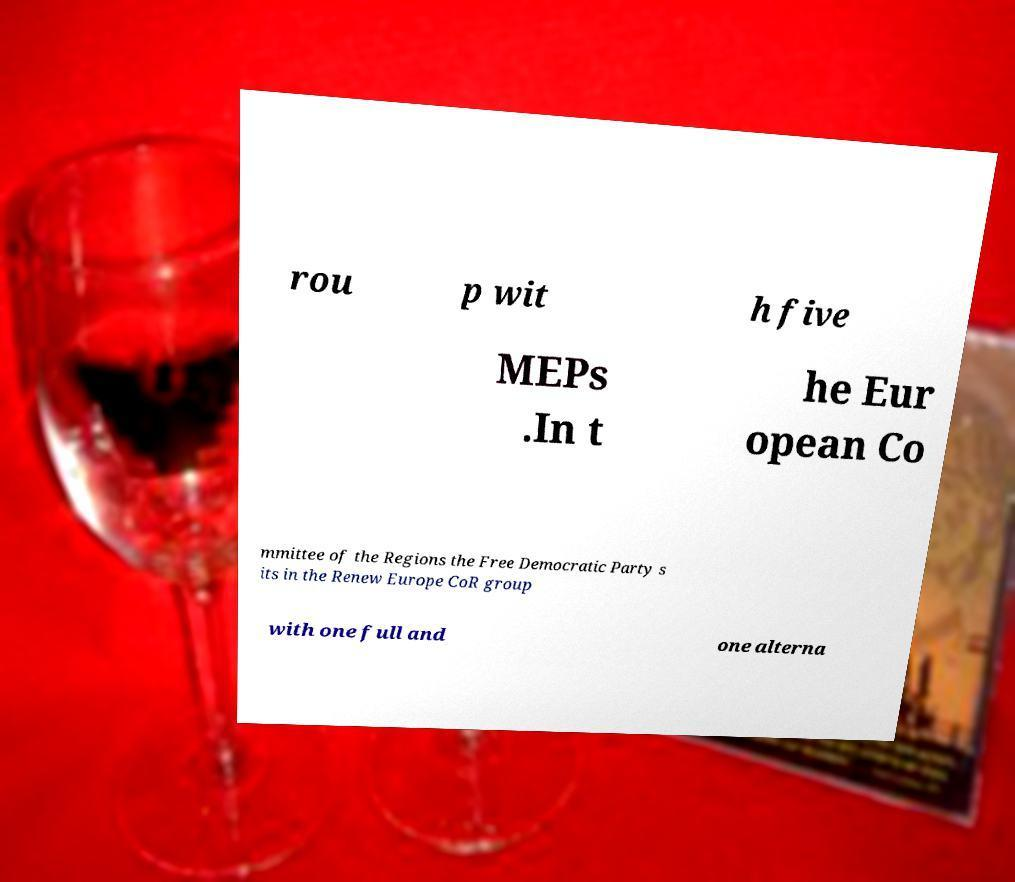What messages or text are displayed in this image? I need them in a readable, typed format. rou p wit h five MEPs .In t he Eur opean Co mmittee of the Regions the Free Democratic Party s its in the Renew Europe CoR group with one full and one alterna 